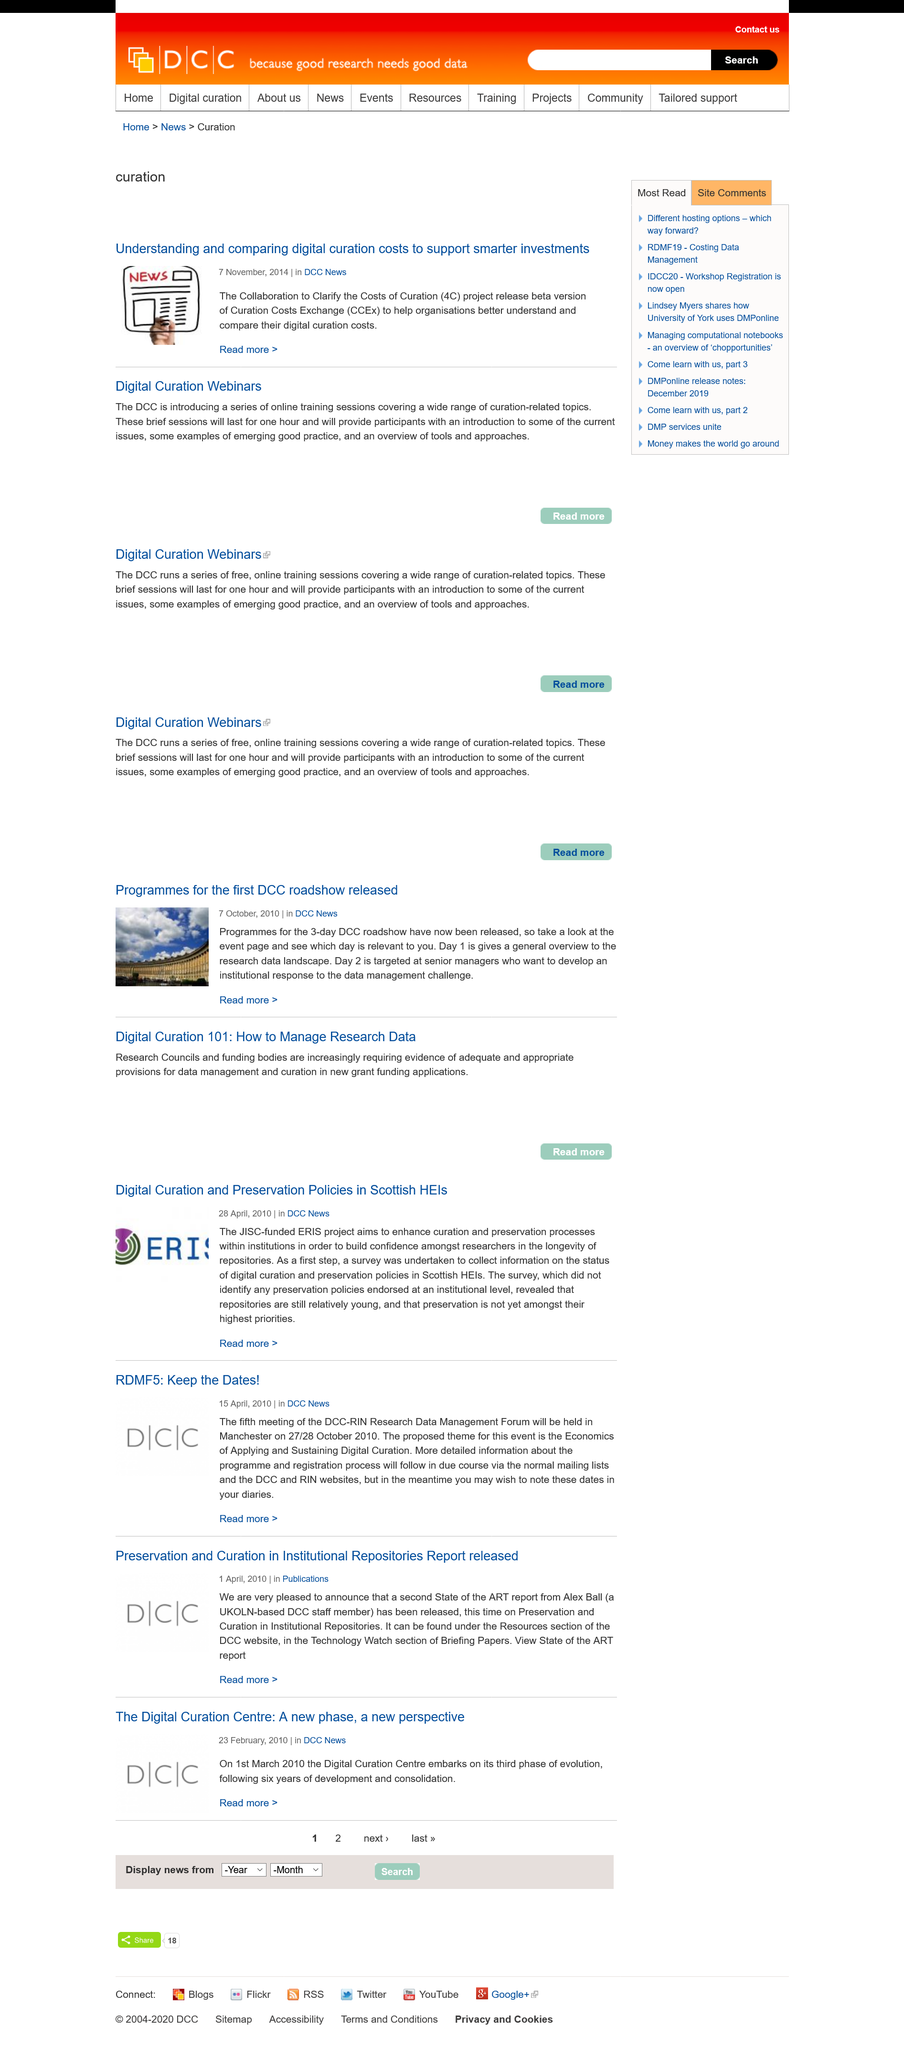List a handful of essential elements in this visual. The article on understanding and comparing digital curation costs to support smaller investments was published in the DCC News category. The acronym CCEx stands for Curation Costs Exchange, which is a platform that facilitates the exchange of costs associated with curating digital collections. The article on understanding and comparing digital curation costs to support smaller investments was published on 7 November, 2014. 